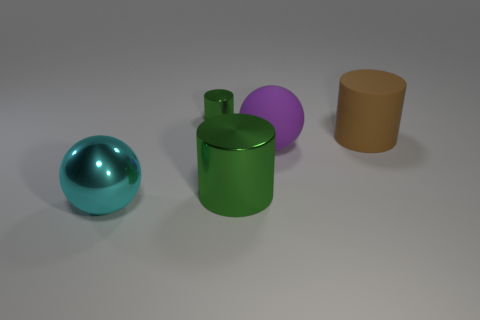Add 1 gray rubber spheres. How many objects exist? 6 Subtract all cylinders. How many objects are left? 2 Subtract all yellow cylinders. Subtract all green shiny cylinders. How many objects are left? 3 Add 2 large purple objects. How many large purple objects are left? 3 Add 3 big matte cylinders. How many big matte cylinders exist? 4 Subtract 0 red balls. How many objects are left? 5 